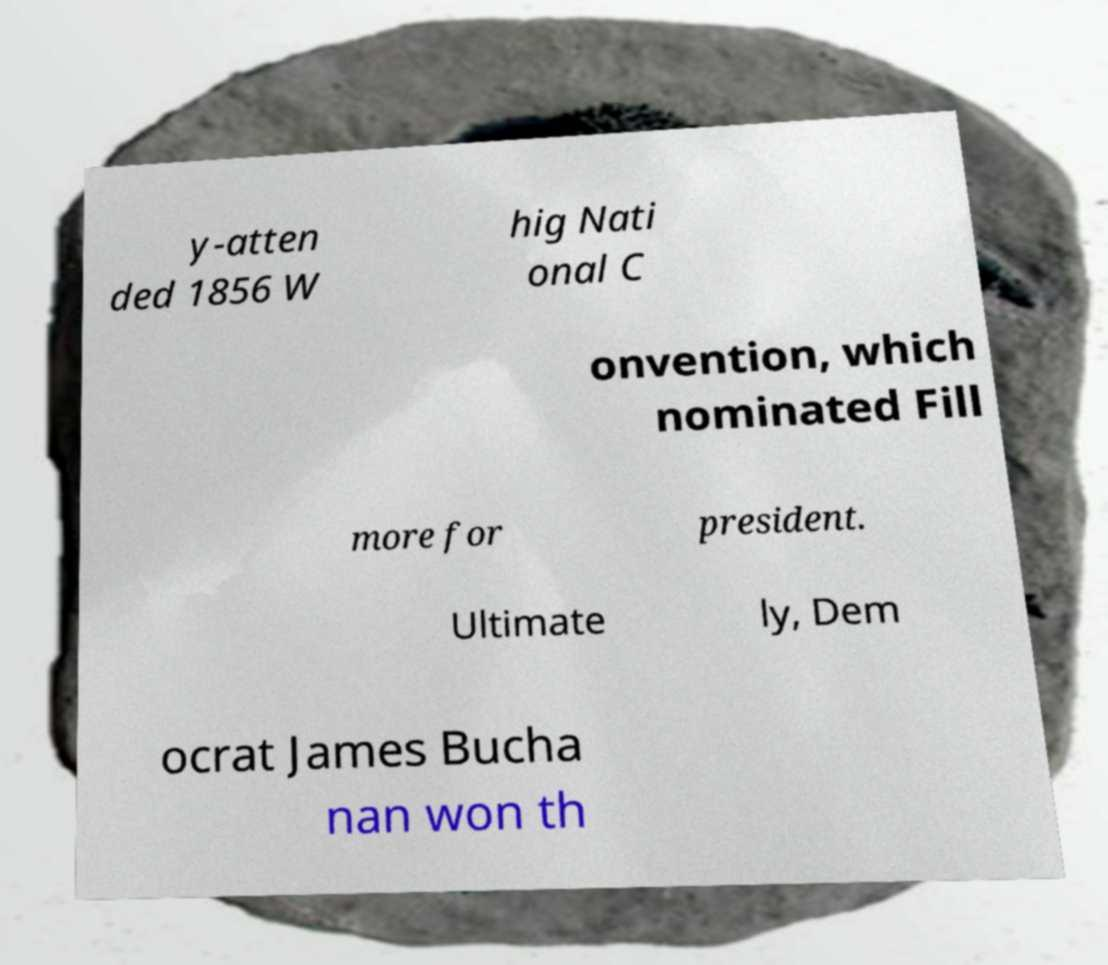For documentation purposes, I need the text within this image transcribed. Could you provide that? y-atten ded 1856 W hig Nati onal C onvention, which nominated Fill more for president. Ultimate ly, Dem ocrat James Bucha nan won th 